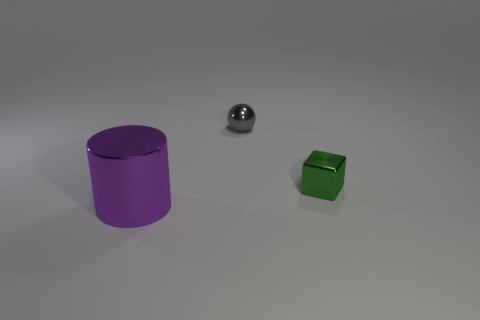How many objects are either brown rubber cylinders or tiny things that are on the right side of the gray thing?
Provide a short and direct response. 1. Is the number of large purple metal cylinders on the right side of the gray ball less than the number of cylinders that are behind the cylinder?
Offer a very short reply. No. What number of other things are the same material as the small gray thing?
Provide a short and direct response. 2. There is a small metal object in front of the tiny metal ball; is its color the same as the large thing?
Ensure brevity in your answer.  No. Is there a small green object that is behind the small shiny object that is on the left side of the block?
Ensure brevity in your answer.  No. What is the thing that is both on the left side of the tiny green metallic block and in front of the tiny gray metallic sphere made of?
Ensure brevity in your answer.  Metal. What is the shape of the tiny object that is the same material as the tiny gray sphere?
Provide a short and direct response. Cube. Are there any other things that are the same shape as the green shiny thing?
Provide a short and direct response. No. Is the thing right of the tiny sphere made of the same material as the sphere?
Make the answer very short. Yes. What is the thing behind the green metallic cube made of?
Keep it short and to the point. Metal. 